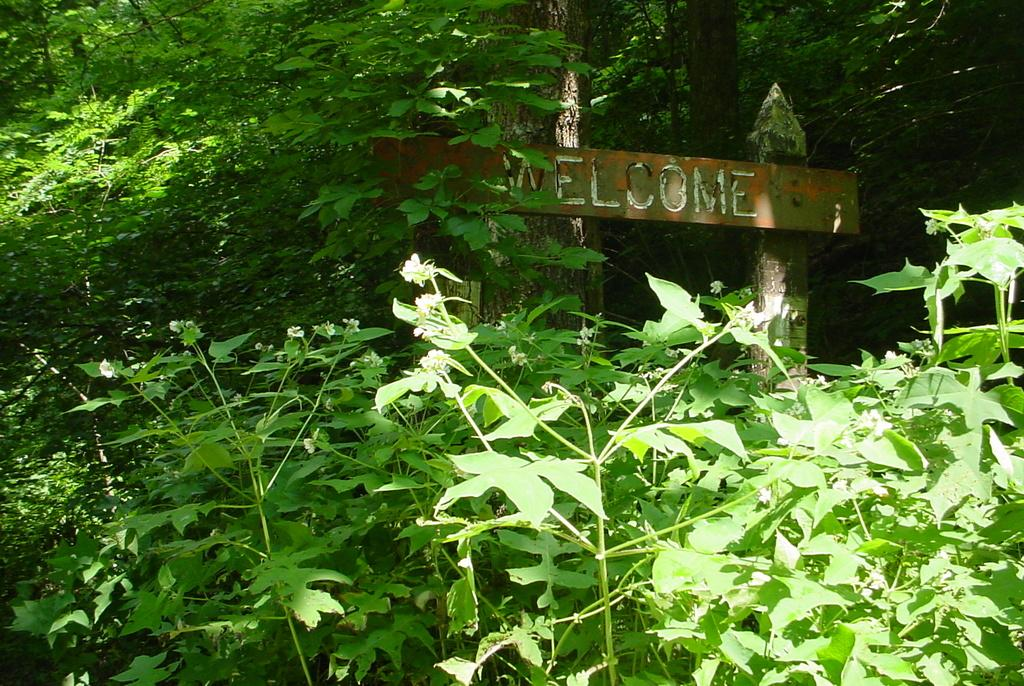What type of living organisms can be seen in the image? Plants and trees are visible in the image. What color are the plants and trees in the image? The plants and trees are green in color. Can you describe the background of the image? There is an arch in the background of the image. What type of work is being done on the plants in the image? There is no indication of any work being done on the plants in the image. What scientific experiments are being conducted on the trees in the image? There is no indication of any scientific experiments being conducted on the trees in the image. 